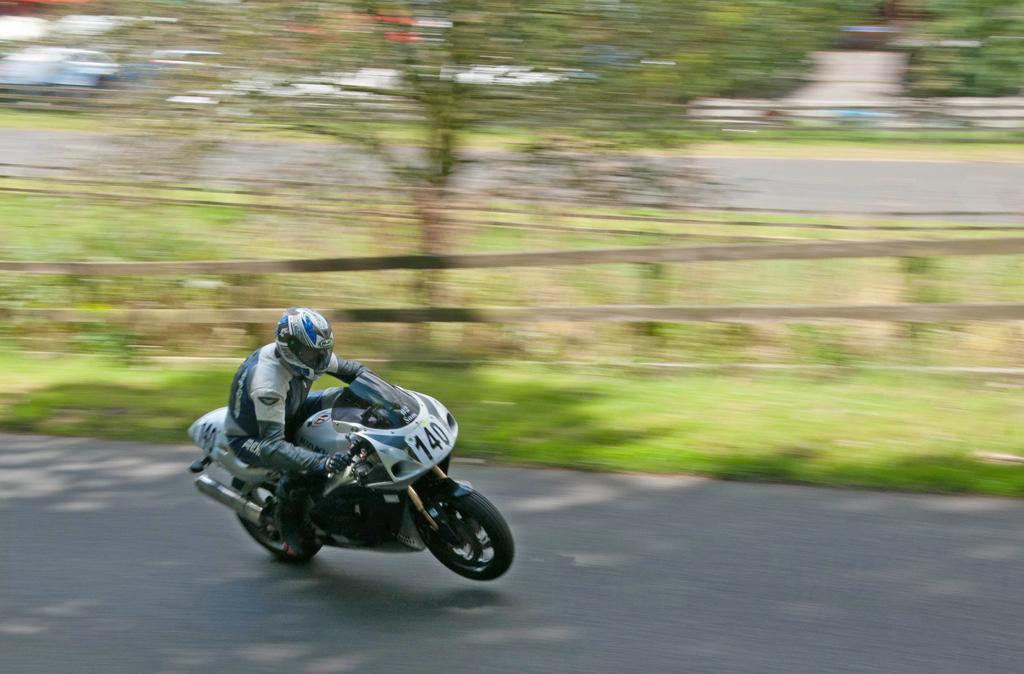What is the person in the image doing? The person is riding a bike in the image. Where is the person riding the bike? The person is on the road. What natural element can be seen in the image? There is a tree visible in the image. What type of barrier is present in the image? There is a wooden fence in the image. What type of writing is visible on the bike in the image? There is no writing visible on the bike in the image. What offer is the person on the bike making to the camera in the image? There is no camera present in the image, and the person is not making any offers. 